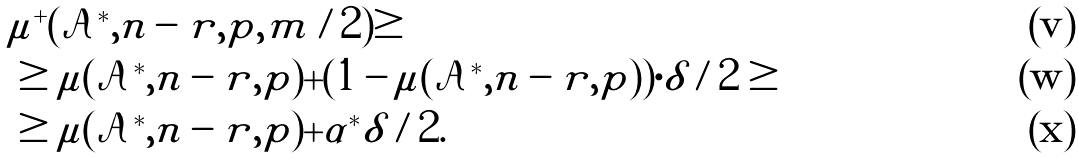Convert formula to latex. <formula><loc_0><loc_0><loc_500><loc_500>& \mu ^ { + } ( \mathcal { A } ^ { * } , n - r , p , m / 2 ) \geq \\ & \geq \mu ( \mathcal { A } ^ { * } , n - r , p ) + ( 1 - \mu ( \mathcal { A } ^ { * } , n - r , p ) ) \cdot \delta / 2 \geq \\ & \geq \mu ( \mathcal { A } ^ { * } , n - r , p ) + \alpha ^ { * } \delta / 2 .</formula> 